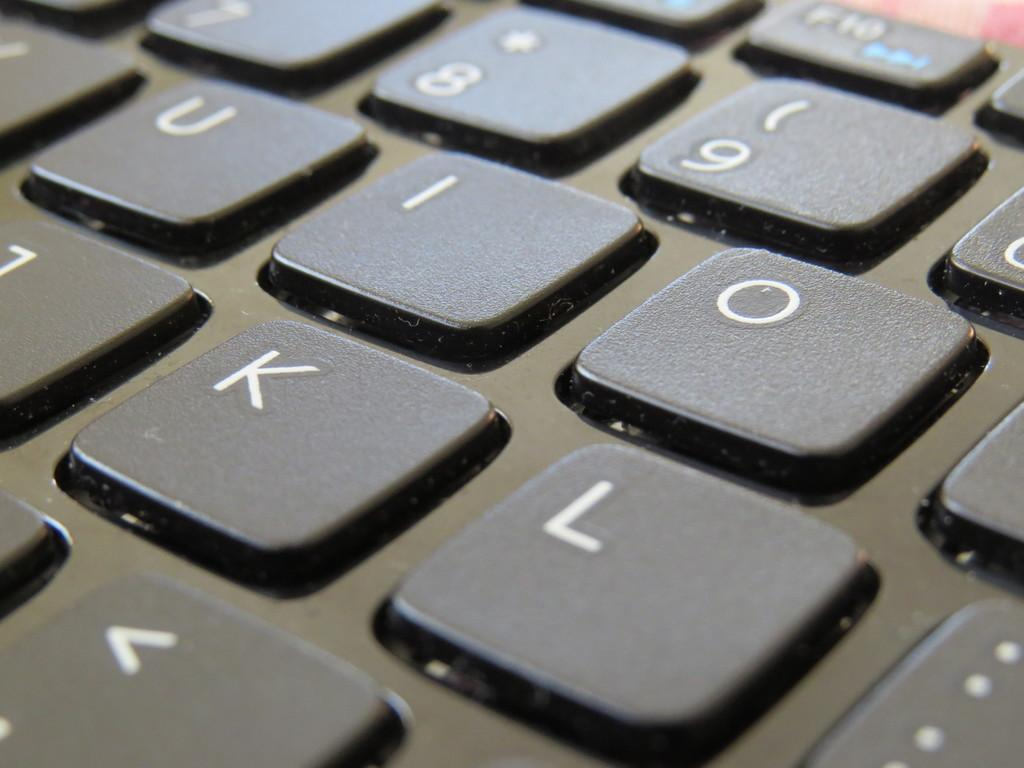<image>
Provide a brief description of the given image. A keyboard shows the U, I and O keys. 